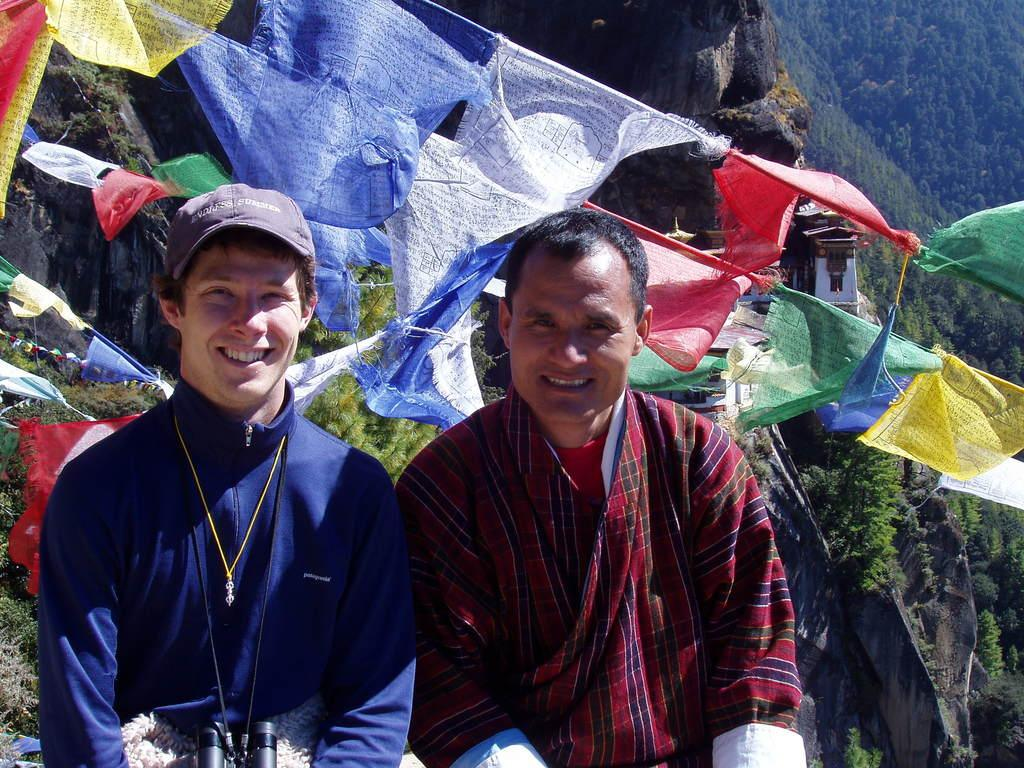How many people are in the image? There are two people in the image. What expressions do the people have? Both people are smiling. Can you describe the man's attire? The man is wearing a binocular and a cap. What can be seen in the background of the image? There are trees, a mountain, clothes with something written on them, and a building far in the background. What type of soda is the man drinking in the image? There is no soda present in the image; the man is wearing a binocular and a cap. Can you tell me how many stockings are visible in the image? There is no mention of stockings in the image; the focus is on the people, their attire, and the background. 